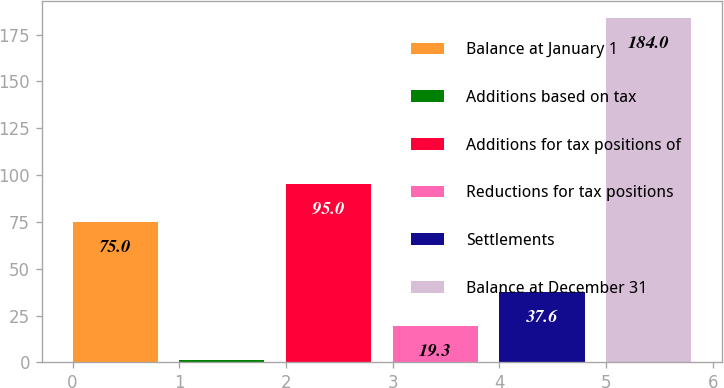Convert chart. <chart><loc_0><loc_0><loc_500><loc_500><bar_chart><fcel>Balance at January 1<fcel>Additions based on tax<fcel>Additions for tax positions of<fcel>Reductions for tax positions<fcel>Settlements<fcel>Balance at December 31<nl><fcel>75<fcel>1<fcel>95<fcel>19.3<fcel>37.6<fcel>184<nl></chart> 